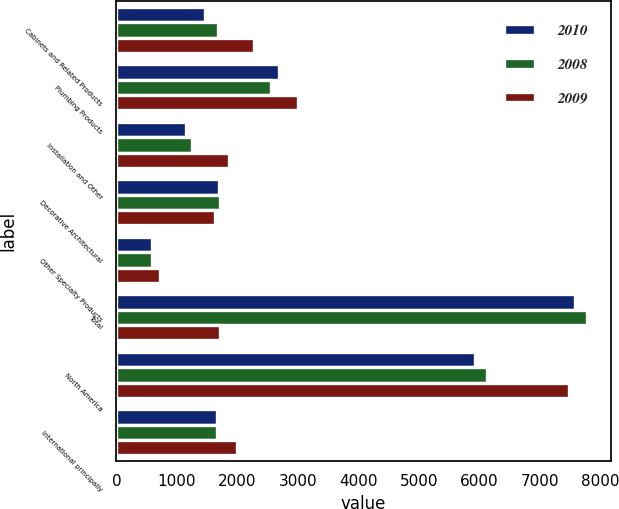Convert chart. <chart><loc_0><loc_0><loc_500><loc_500><stacked_bar_chart><ecel><fcel>Cabinets and Related Products<fcel>Plumbing Products<fcel>Installation and Other<fcel>Decorative Architectural<fcel>Other Specialty Products<fcel>Total<fcel>North America<fcel>International principally<nl><fcel>2010<fcel>1464<fcel>2692<fcel>1147<fcel>1693<fcel>596<fcel>7592<fcel>5929<fcel>1663<nl><fcel>2008<fcel>1674<fcel>2564<fcel>1256<fcel>1714<fcel>584<fcel>7792<fcel>6135<fcel>1657<nl><fcel>2009<fcel>2276<fcel>3002<fcel>1861<fcel>1629<fcel>716<fcel>1714<fcel>7482<fcel>2002<nl></chart> 